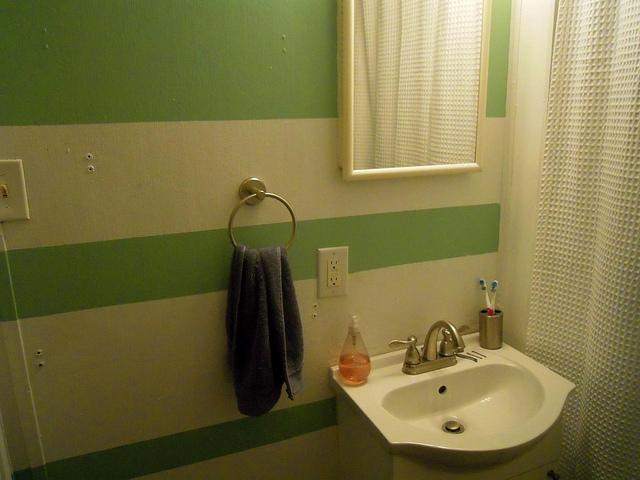How many towels are hanging not folded?
Answer briefly. 1. What is hanging on the wall?
Be succinct. Towel. What colors are the stripes?
Be succinct. Green. How many toothbrushes are there in the cup?
Answer briefly. 2. 